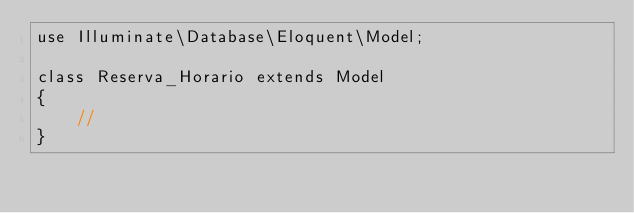<code> <loc_0><loc_0><loc_500><loc_500><_PHP_>use Illuminate\Database\Eloquent\Model;

class Reserva_Horario extends Model
{
    //
}
</code> 